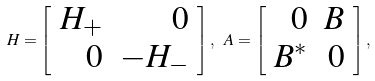Convert formula to latex. <formula><loc_0><loc_0><loc_500><loc_500>H = \left [ \begin{array} { r r } H _ { + } & 0 \\ 0 & - H _ { - } \\ \end{array} \right ] , \ A = \left [ \begin{array} { r r } 0 & B \\ B ^ { * } & 0 \\ \end{array} \right ] , \</formula> 